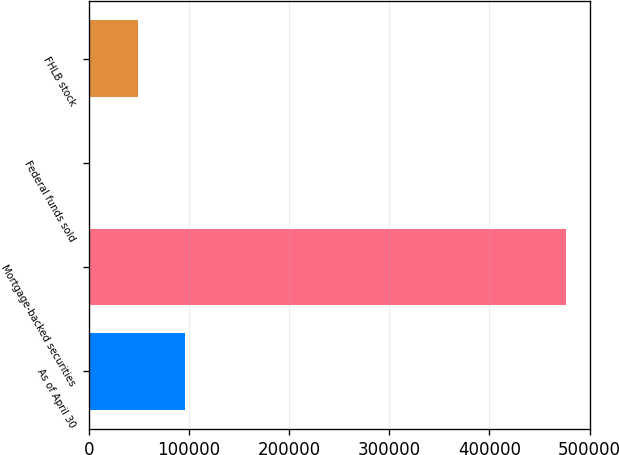<chart> <loc_0><loc_0><loc_500><loc_500><bar_chart><fcel>As of April 30<fcel>Mortgage-backed securities<fcel>Federal funds sold<fcel>FHLB stock<nl><fcel>96225.2<fcel>476450<fcel>1169<fcel>48697.1<nl></chart> 